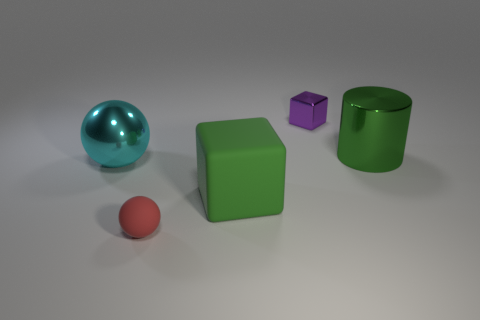Subtract 1 balls. How many balls are left? 1 Subtract all blue cylinders. How many green balls are left? 0 Add 4 cyan objects. How many cyan objects exist? 5 Add 1 large green spheres. How many objects exist? 6 Subtract all purple blocks. How many blocks are left? 1 Subtract 1 cyan balls. How many objects are left? 4 Subtract all cubes. How many objects are left? 3 Subtract all gray balls. Subtract all green cylinders. How many balls are left? 2 Subtract all large green cubes. Subtract all green metal cylinders. How many objects are left? 3 Add 2 small red matte spheres. How many small red matte spheres are left? 3 